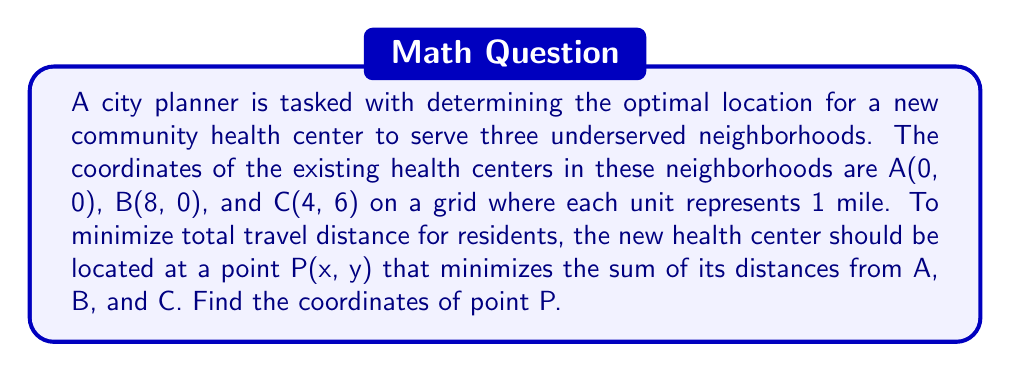What is the answer to this math problem? To solve this problem, we'll use the distance formula and calculus to minimize the total distance.

1) Let's define the function $f(x,y)$ as the sum of distances from P to A, B, and C:

   $$f(x,y) = \sqrt{x^2 + y^2} + \sqrt{(x-8)^2 + y^2} + \sqrt{(x-4)^2 + (y-6)^2}$$

2) To find the minimum, we need to find where the partial derivatives of $f$ with respect to $x$ and $y$ are both zero:

   $$\frac{\partial f}{\partial x} = \frac{x}{\sqrt{x^2 + y^2}} + \frac{x-8}{\sqrt{(x-8)^2 + y^2}} + \frac{x-4}{\sqrt{(x-4)^2 + (y-6)^2}} = 0$$

   $$\frac{\partial f}{\partial y} = \frac{y}{\sqrt{x^2 + y^2}} + \frac{y}{\sqrt{(x-8)^2 + y^2}} + \frac{y-6}{\sqrt{(x-4)^2 + (y-6)^2}} = 0$$

3) These equations are complex and don't have a simple algebraic solution. However, we can observe that the triangle ABC is a right triangle with its right angle at B.

4) In such a configuration, the point that minimizes the sum of distances to the vertices of a right triangle is known as the Fermat point, which coincides with the isogonic center of the triangle.

5) For a right triangle, the isogonic center is located at the point where the hypotenuse intersects the arc of a circle that has the hypotenuse as its diameter.

6) In our case, the hypotenuse is AC, which can be represented by the line equation:

   $$y = \frac{3}{2}x$$

7) The midpoint of AC is $(\frac{4}{2}, \frac{6}{2}) = (2, 3)$. This is the center of our circle.

8) The radius of the circle is half the length of AC:

   $$r = \frac{1}{2}\sqrt{4^2 + 6^2} = \frac{1}{2}\sqrt{52} = \frac{\sqrt{13}}{2}$$

9) The equation of the circle is:

   $$(x-2)^2 + (y-3)^2 = (\frac{\sqrt{13}}{2})^2$$

10) Solving the system of equations from steps 6 and 9:

    $$y = \frac{3}{2}x$$
    $$(x-2)^2 + (\frac{3}{2}x-3)^2 = (\frac{\sqrt{13}}{2})^2$$

11) This system can be solved to find x, and then y:

    $$x = 4 - \frac{\sqrt{13}}{2} \approx 2.1926$$
    $$y = \frac{3}{2}(4 - \frac{\sqrt{13}}{2}) \approx 3.2889$$

Therefore, the optimal location for the new community health center is approximately (2.1926, 3.2889).
Answer: The coordinates of the optimal location P are $(4 - \frac{\sqrt{13}}{2}, \frac{3}{2}(4 - \frac{\sqrt{13}}{2}))$, or approximately (2.1926, 3.2889) miles. 